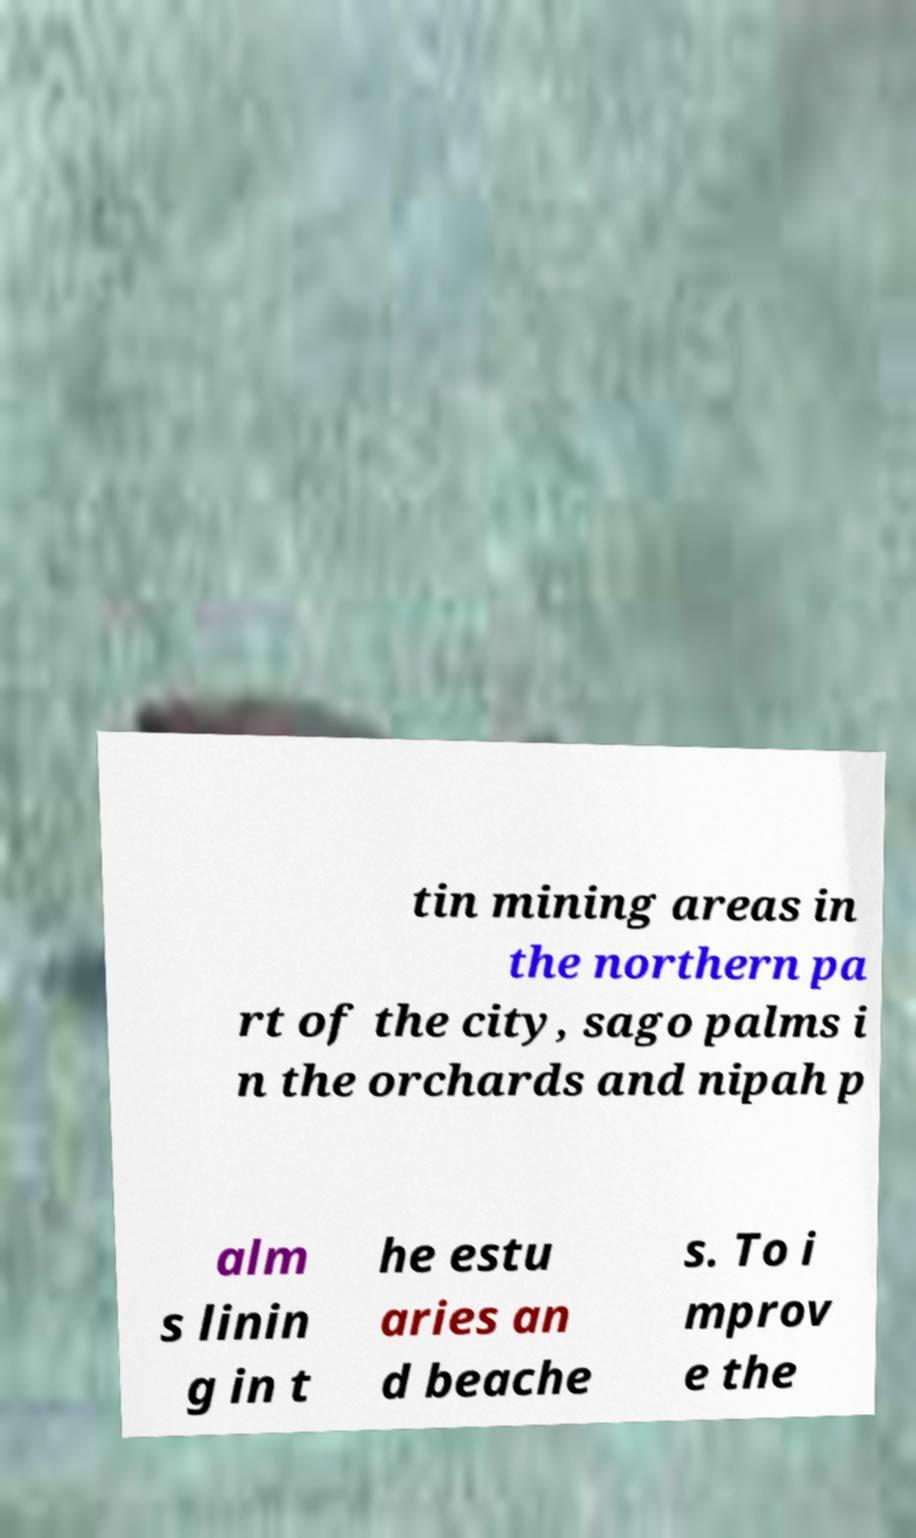I need the written content from this picture converted into text. Can you do that? tin mining areas in the northern pa rt of the city, sago palms i n the orchards and nipah p alm s linin g in t he estu aries an d beache s. To i mprov e the 